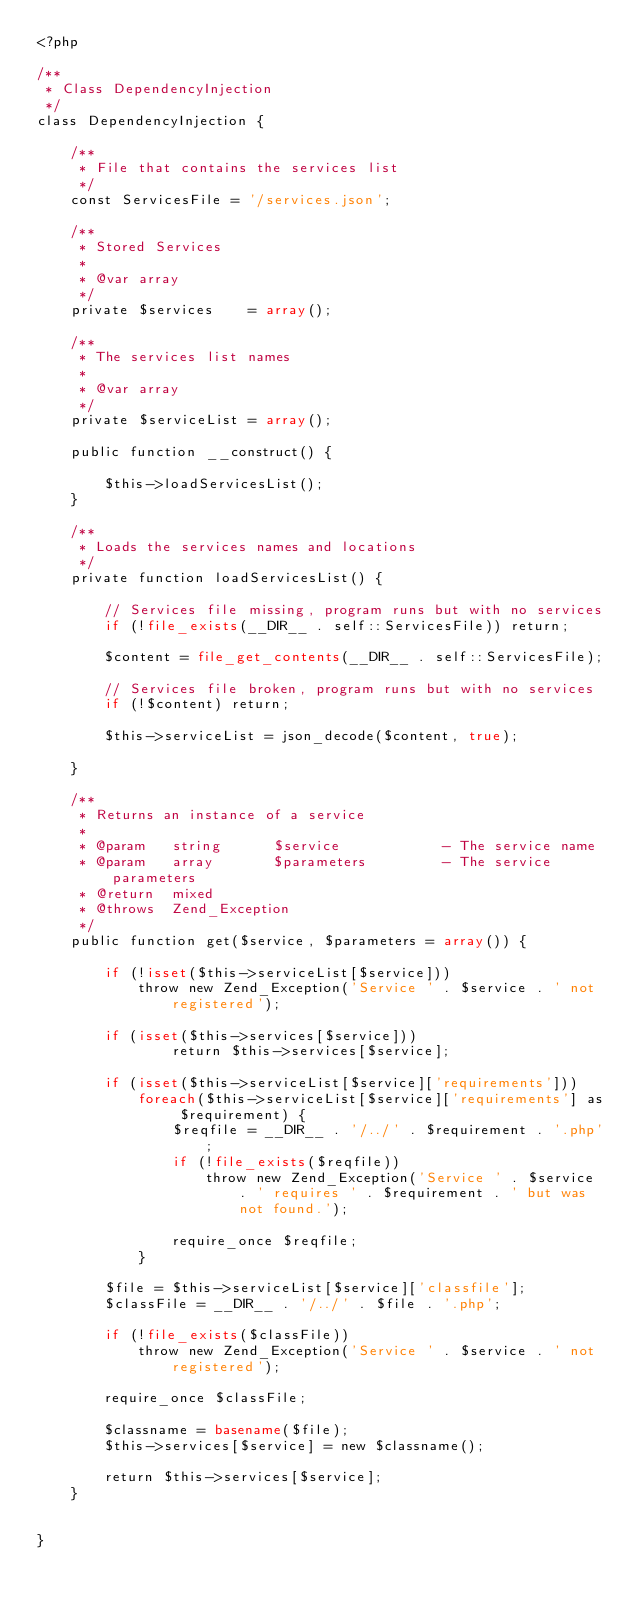Convert code to text. <code><loc_0><loc_0><loc_500><loc_500><_PHP_><?php

/**
 * Class DependencyInjection
 */
class DependencyInjection {

    /**
     * File that contains the services list
     */
    const ServicesFile = '/services.json';

    /**
     * Stored Services
     *
     * @var array
     */
    private $services    = array();

    /**
     * The services list names
     *
     * @var array
     */
    private $serviceList = array();

    public function __construct() {

        $this->loadServicesList();
    }

    /**
     * Loads the services names and locations
     */
    private function loadServicesList() {

        // Services file missing, program runs but with no services
        if (!file_exists(__DIR__ . self::ServicesFile)) return;

        $content = file_get_contents(__DIR__ . self::ServicesFile);

        // Services file broken, program runs but with no services
        if (!$content) return;

        $this->serviceList = json_decode($content, true);

    }

    /**
     * Returns an instance of a service
     *
     * @param   string      $service            - The service name
     * @param   array       $parameters         - The service parameters
     * @return  mixed
     * @throws  Zend_Exception
     */
    public function get($service, $parameters = array()) {

        if (!isset($this->serviceList[$service]))
            throw new Zend_Exception('Service ' . $service . ' not registered');

        if (isset($this->services[$service]))
                return $this->services[$service];

        if (isset($this->serviceList[$service]['requirements']))
            foreach($this->serviceList[$service]['requirements'] as $requirement) {
                $reqfile = __DIR__ . '/../' . $requirement . '.php';
                if (!file_exists($reqfile))
                    throw new Zend_Exception('Service ' . $service . ' requires ' . $requirement . ' but was not found.');

                require_once $reqfile;
            }

        $file = $this->serviceList[$service]['classfile'];
        $classFile = __DIR__ . '/../' . $file . '.php';

        if (!file_exists($classFile))
            throw new Zend_Exception('Service ' . $service . ' not registered');

        require_once $classFile;

        $classname = basename($file);
        $this->services[$service] = new $classname();

        return $this->services[$service];
    }


}</code> 